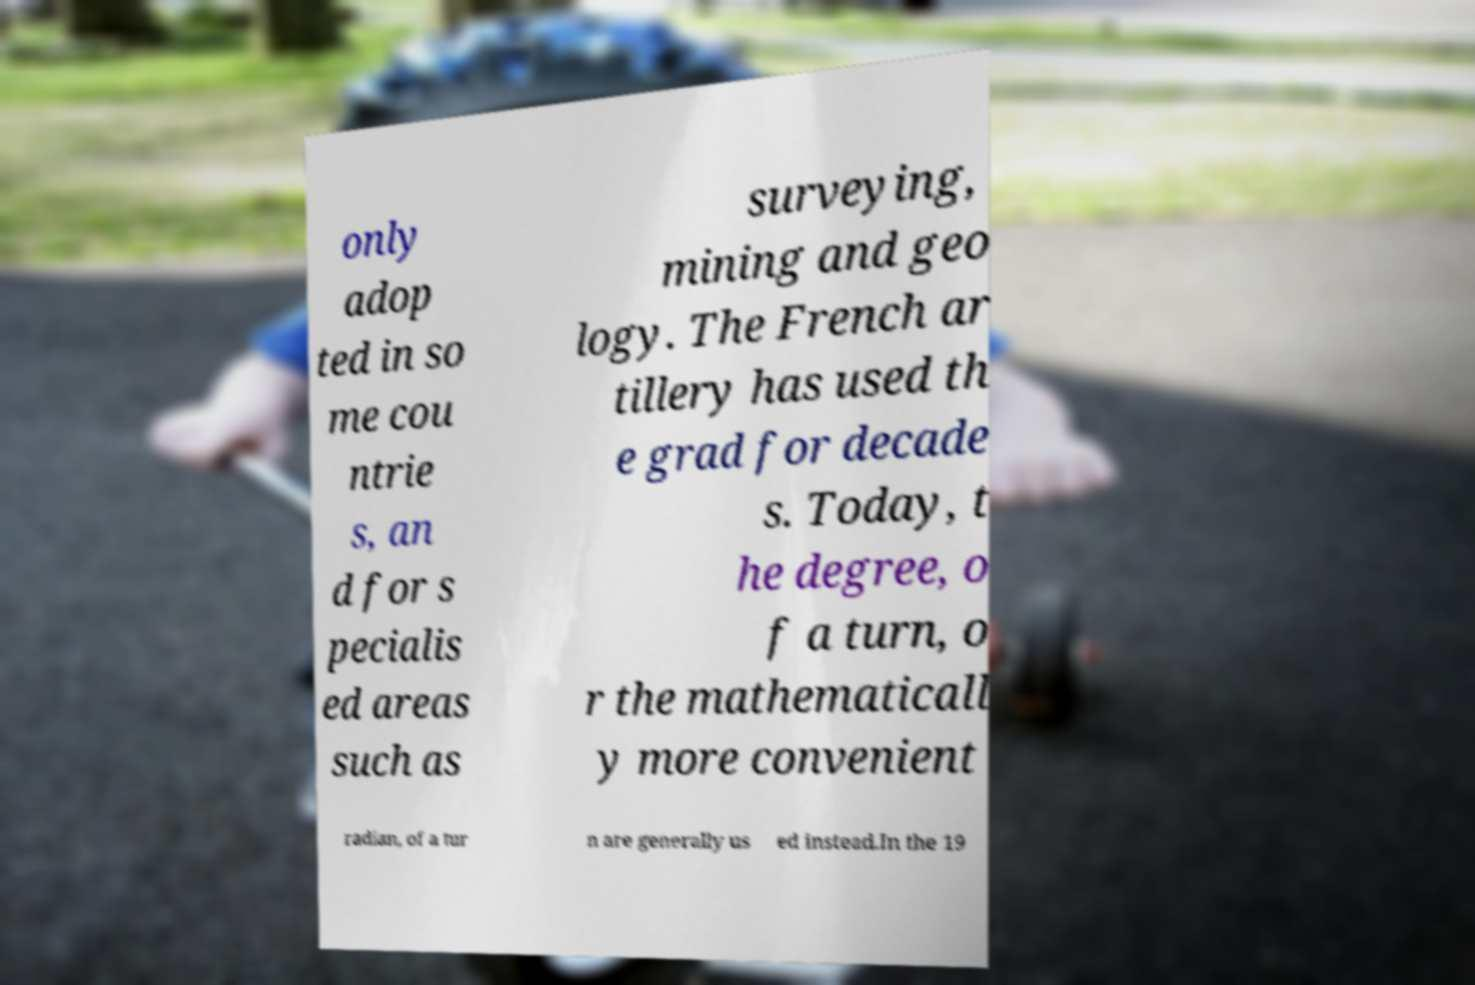Could you assist in decoding the text presented in this image and type it out clearly? only adop ted in so me cou ntrie s, an d for s pecialis ed areas such as surveying, mining and geo logy. The French ar tillery has used th e grad for decade s. Today, t he degree, o f a turn, o r the mathematicall y more convenient radian, of a tur n are generally us ed instead.In the 19 